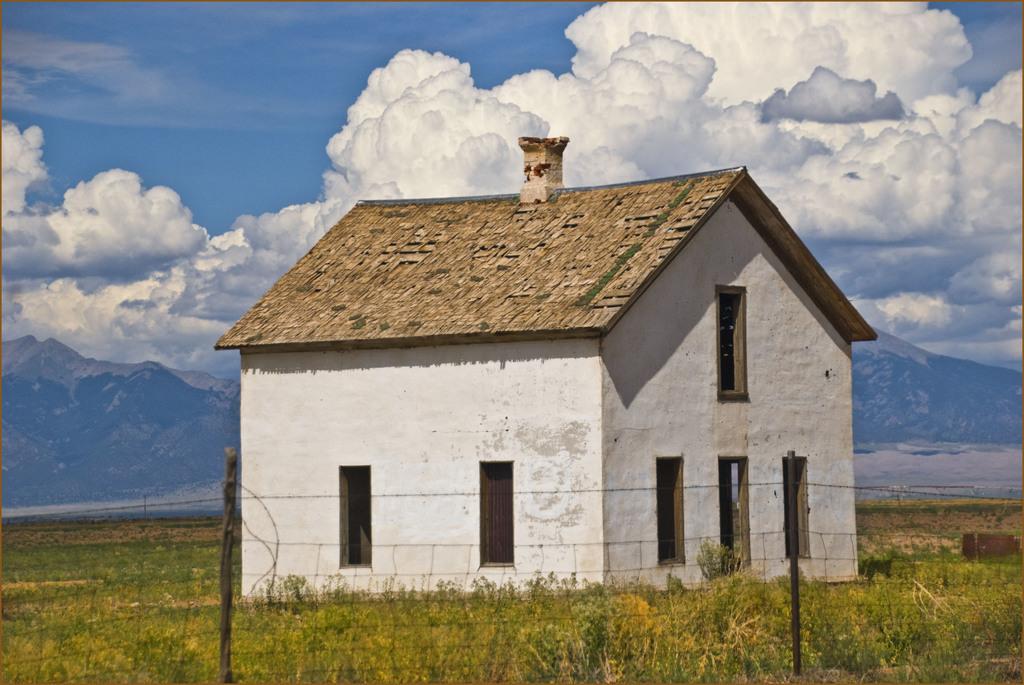Describe this image in one or two sentences. At the center of the image there is a house, in front of the house there is a grass. In the background there is a sky with clouds. 